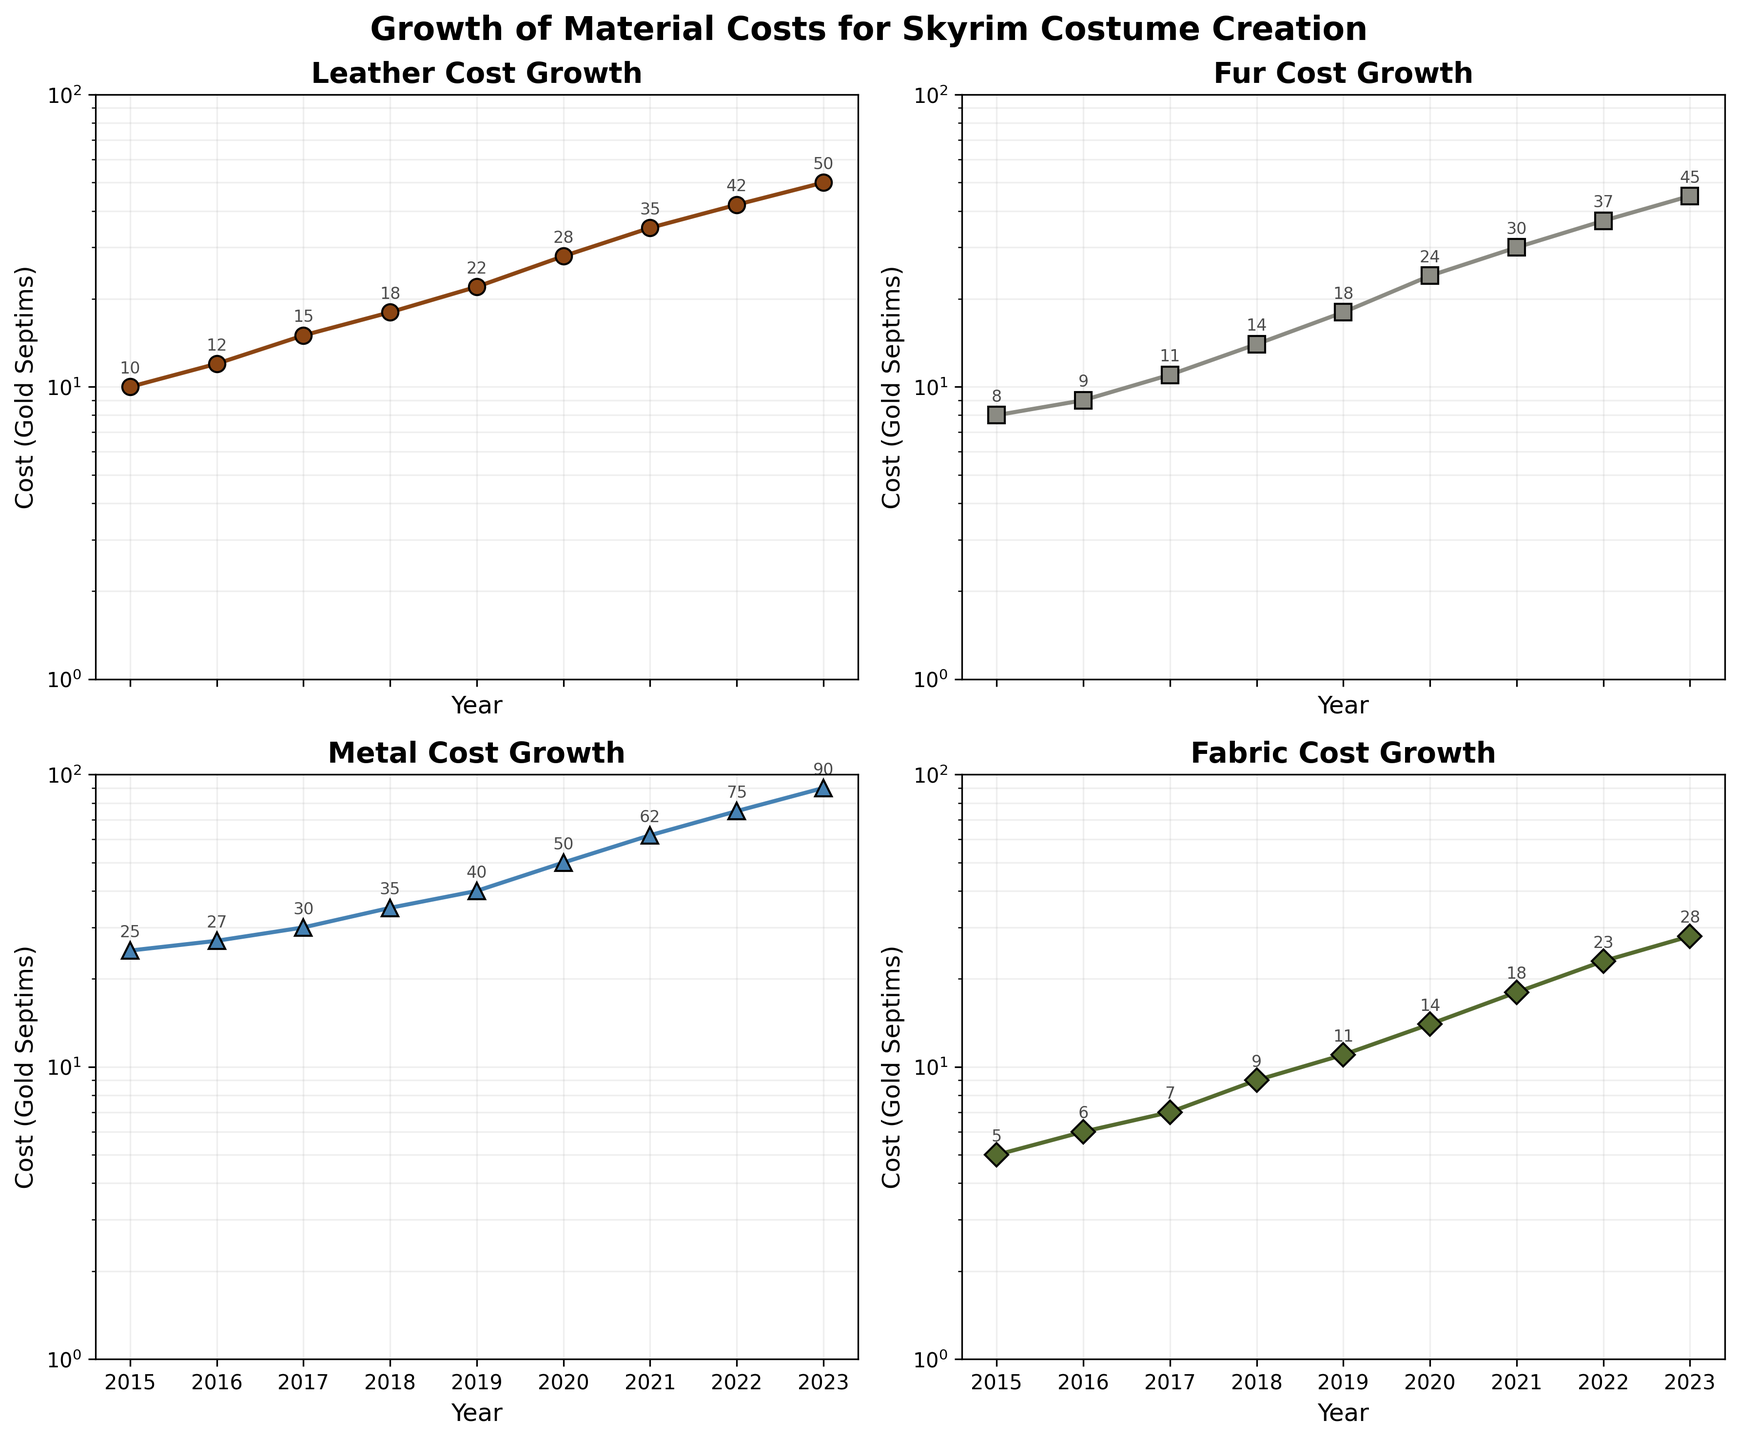What is the title of the entire figure? The title of a figure is usually displayed at the top center. In the provided plot, it reads 'Growth of Material Costs for Skyrim Costume Creation'.
Answer: Growth of Material Costs for Skyrim Costume Creation Which material had the highest cost in 2023? By observing the vertical position of the data points for 2023 in each subplot, Metal shows the highest cost at 90 Gold Septims.
Answer: Metal How many different materials are displayed in the figure? The figure has four subplots, each representing a different material: Leather, Fur, Metal, and Fabric.
Answer: 4 What is the axis label for the X-axis? Examine the label along the horizontal axis of each subplot; it's labeled 'Year'.
Answer: Year What is the cost range displayed on the Y-axis for all subplots? The Y-axis for each subplot is marked from 1 to 100 Gold Septims.
Answer: 1 to 100 Between which years did the cost of Leather increase the most? Look at the data points in the Leather subplot. The cost jump between 2019 and 2020 is the largest (22 to 28 Gold Septims).
Answer: 2019 to 2020 In which year did the cost of Fabric surpass 10 Gold Septims? Observe the Fabric subplot and find the year when the cost goes beyond 10. It happens in 2019 where the cost reaches 11 Gold Septims.
Answer: 2019 Compare the 2022 costs of Fur and Fabric. Which one is higher and by how much? Fur costs 37 and Fabric costs 23 in 2022. The difference is 37 - 23 = 14 Gold Septims.
Answer: Fur is higher by 14 Which material had the most steady increase in cost from 2015 to 2023? Comparing the slopes visually, Fabric shows the steadiest, most uniform increase across the years.
Answer: Fabric On what plot type is the data displayed, and what is unique about its axes? The data is displayed on subplots that use a logarithmic (log) scale on the Y-axis, making it easier to visualize growth over multiple orders of magnitude.
Answer: Subplots with log scale Y-axes 